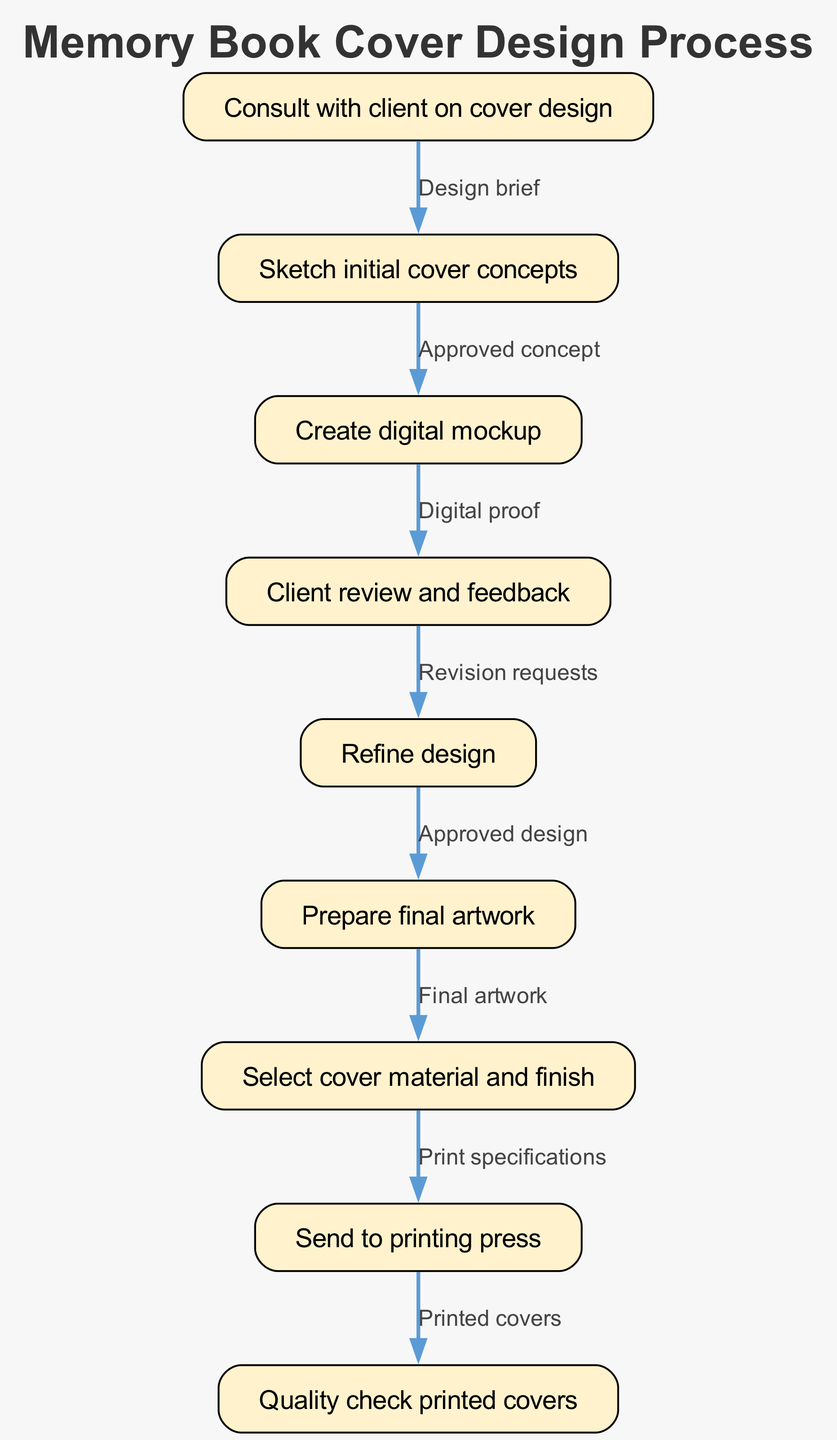What is the first step in the design process? The first step in the process is outlined in node 1, which states "Consult with client on cover design". This node is the starting point of the flowchart and sets the stage for the entire procedure.
Answer: Consult with client on cover design How many nodes are there in the diagram? To determine the number of nodes, we can count each unique step represented in the diagram. According to the data provided, there are 9 nodes, each representing a different stage in the design process.
Answer: 9 What is the output of the stage after "Client review and feedback"? After "Client review and feedback", the process moves to node 5, which is "Refine design". This indicates that feedback is typically used to alter and improve the design.
Answer: Refine design What dictates the transition from "Create digital mockup" to the next step? The transition from "Create digital mockup" (node 3) to "Client review and feedback" (node 4) is dictated by the completion of a "Digital proof". This concept serves as the justification for this transition.
Answer: Digital proof Which node comes before "Prepare final artwork"? The node that comes before "Prepare final artwork" is "Refine design" (node 5). The flowchart shows that once the design is approved, the next logical step is to prepare the final artwork for printing.
Answer: Refine design How many edges connect the nodes in the process? To find the number of edges, we can count the lines connecting each node in the flowchart. The data shows 8 edges, signifying the transitions between stages in the design process.
Answer: 8 What step follows "Select cover material and finish"? The step that follows "Select cover material and finish" (node 7) is "Send to printing press" (node 8). This progression indicates the material decisions are finalized before printing.
Answer: Send to printing press What demonstrates the reason for moving from "Refine design" to "Prepare final artwork"? The movement from "Refine design" to "Prepare final artwork" happens upon "Approved design". This means that the design must receive client approval before it can be finalized for printing.
Answer: Approved design 